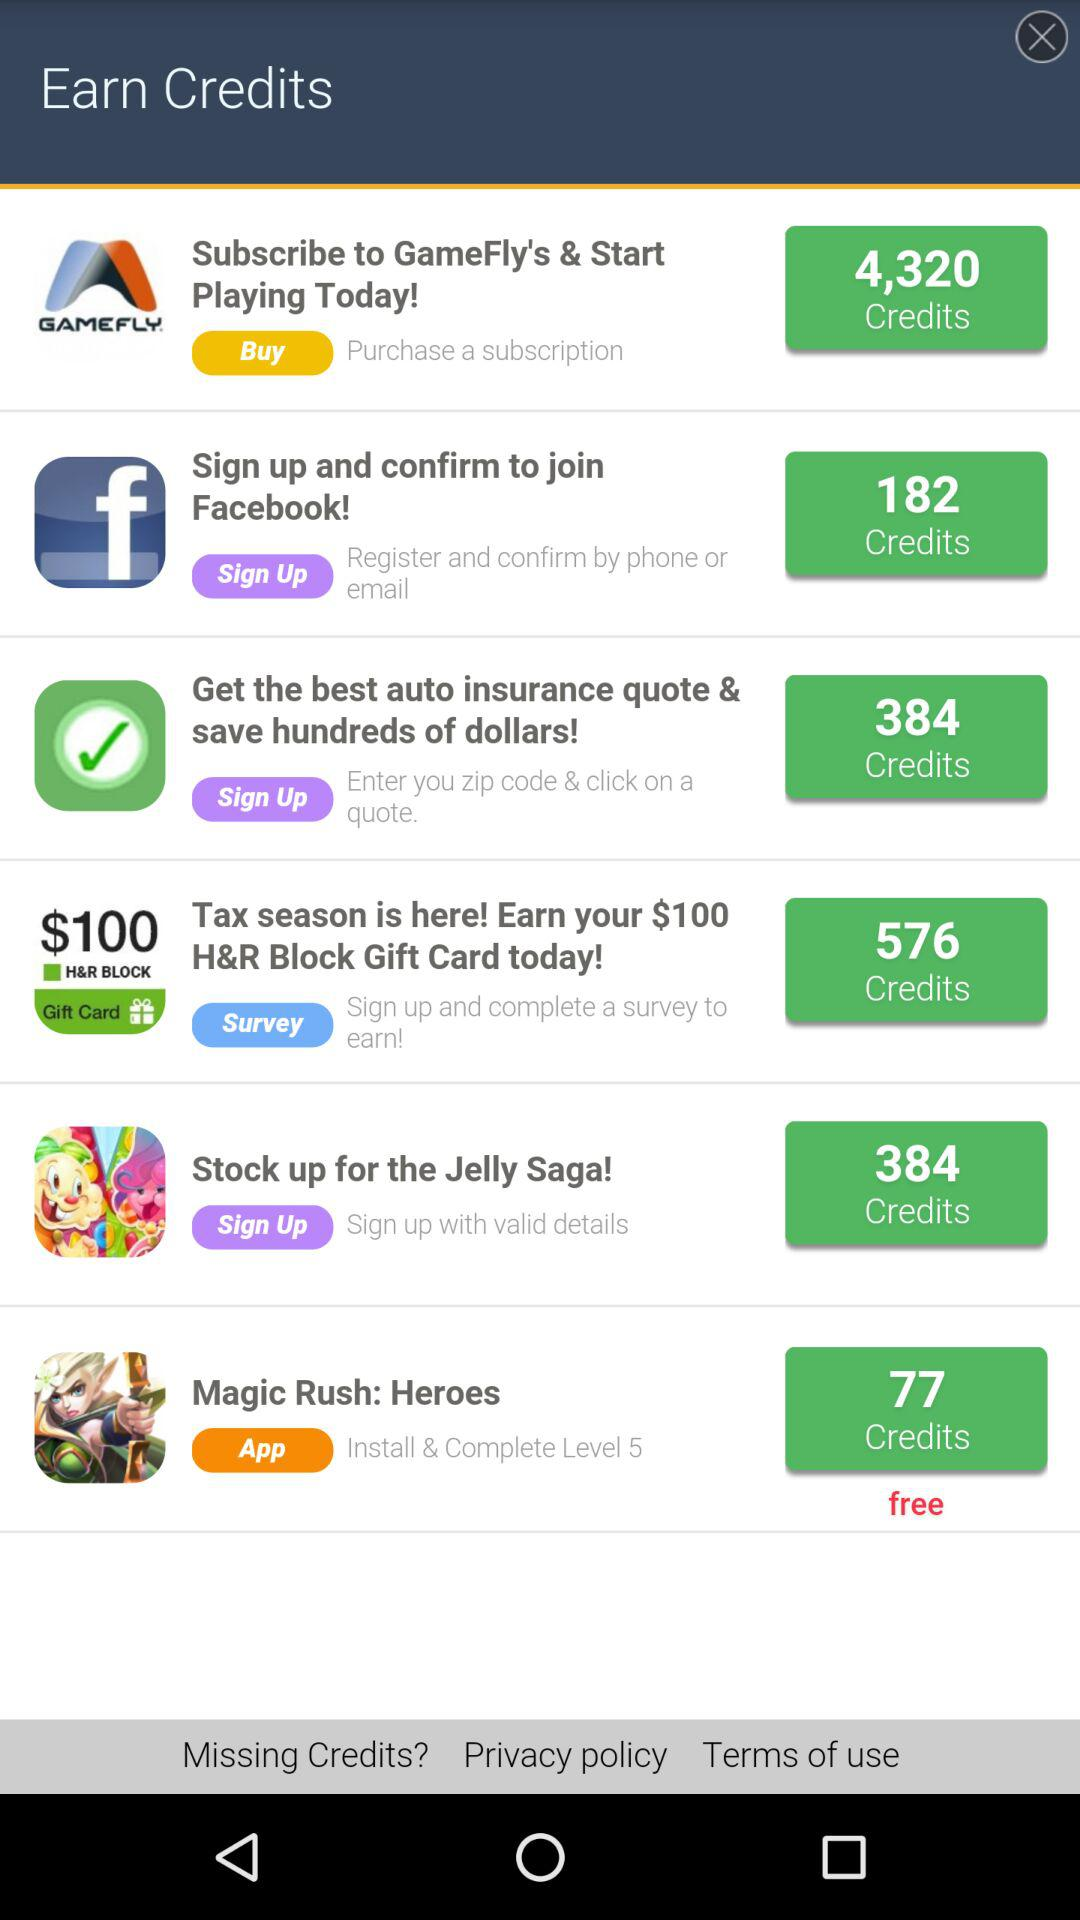What's the complete level number of the Magic Rush Heroes application? The complete level number is 5. 